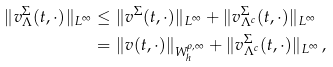Convert formula to latex. <formula><loc_0><loc_0><loc_500><loc_500>\| v ^ { \Sigma } _ { \Lambda } ( t , \cdot ) \| _ { L ^ { \infty } } & \leq \| v ^ { \Sigma } ( t , \cdot ) \| _ { L ^ { \infty } } + \| v ^ { \Sigma } _ { \Lambda ^ { c } } ( t , \cdot ) \| _ { L ^ { \infty } } \\ & = \| v ( t , \cdot ) \| _ { W _ { h } ^ { \rho , \infty } } + \| v ^ { \Sigma } _ { \Lambda ^ { c } } ( t , \cdot ) \| _ { L ^ { \infty } } \, ,</formula> 